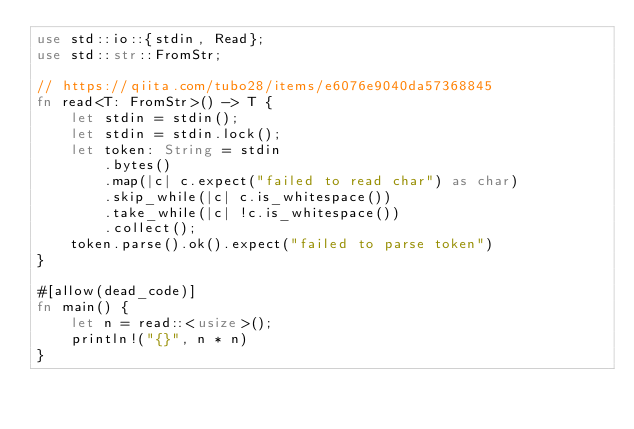<code> <loc_0><loc_0><loc_500><loc_500><_Rust_>use std::io::{stdin, Read};
use std::str::FromStr;

// https://qiita.com/tubo28/items/e6076e9040da57368845
fn read<T: FromStr>() -> T {
    let stdin = stdin();
    let stdin = stdin.lock();
    let token: String = stdin
        .bytes()
        .map(|c| c.expect("failed to read char") as char)
        .skip_while(|c| c.is_whitespace())
        .take_while(|c| !c.is_whitespace())
        .collect();
    token.parse().ok().expect("failed to parse token")
}

#[allow(dead_code)]
fn main() {
    let n = read::<usize>();
    println!("{}", n * n)
}
</code> 